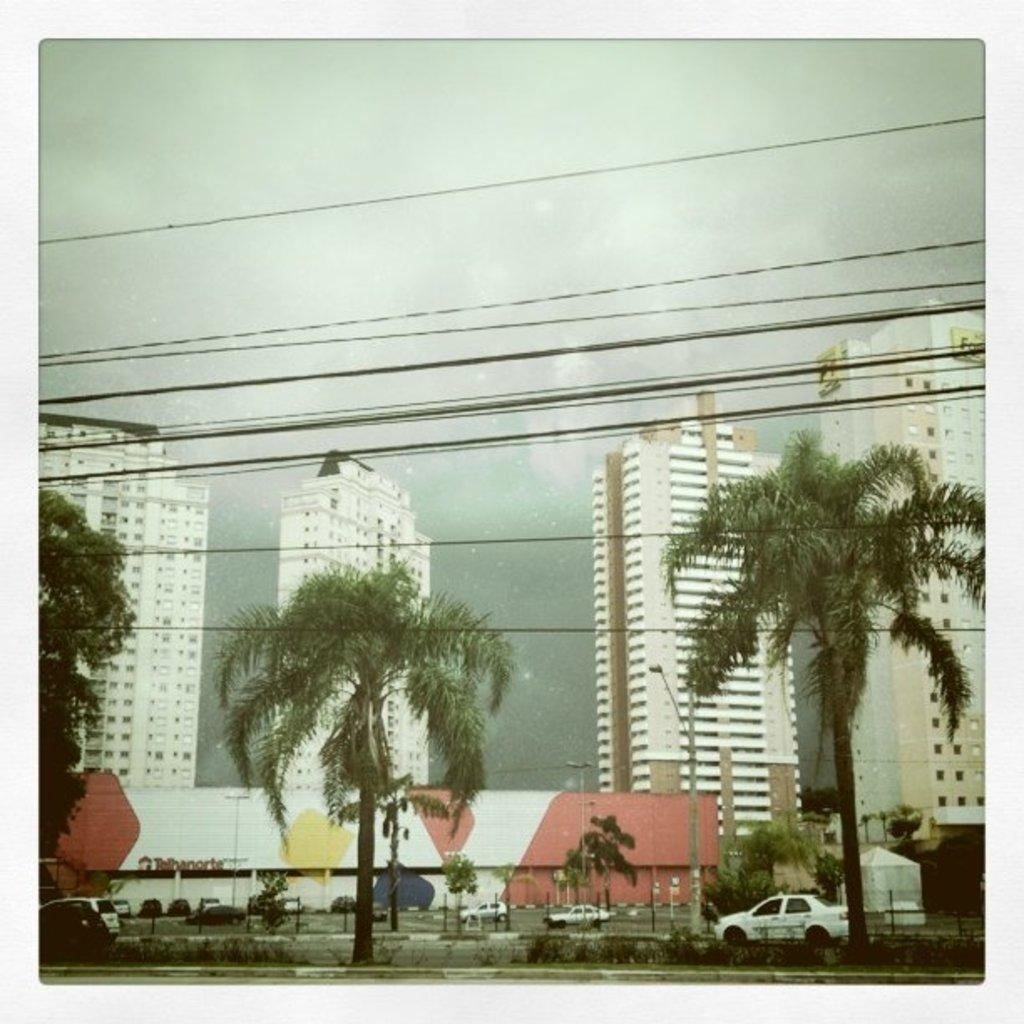What can be seen on the road in the image? There are cars on the road in the image. What type of natural elements are visible in the background of the image? There are trees in the background of the image. What man-made structures can be seen in the background of the image? There are poles, buildings, and wires in the background of the image. What part of the natural environment is visible in the background of the image? The sky is visible in the background of the image. What type of straw is being used to create the amusement in the image? There is no straw or amusement present in the image; it features cars on the road and various background elements. 